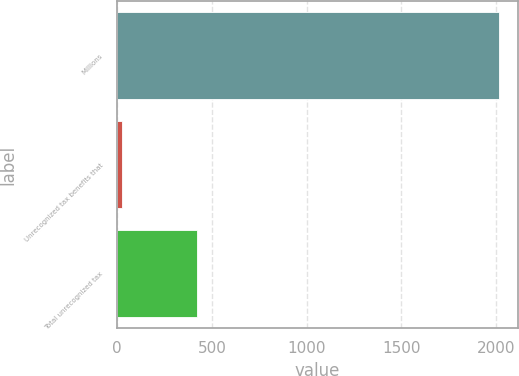Convert chart to OTSL. <chart><loc_0><loc_0><loc_500><loc_500><bar_chart><fcel>Millions<fcel>Unrecognized tax benefits that<fcel>Total unrecognized tax<nl><fcel>2013<fcel>25<fcel>422.6<nl></chart> 